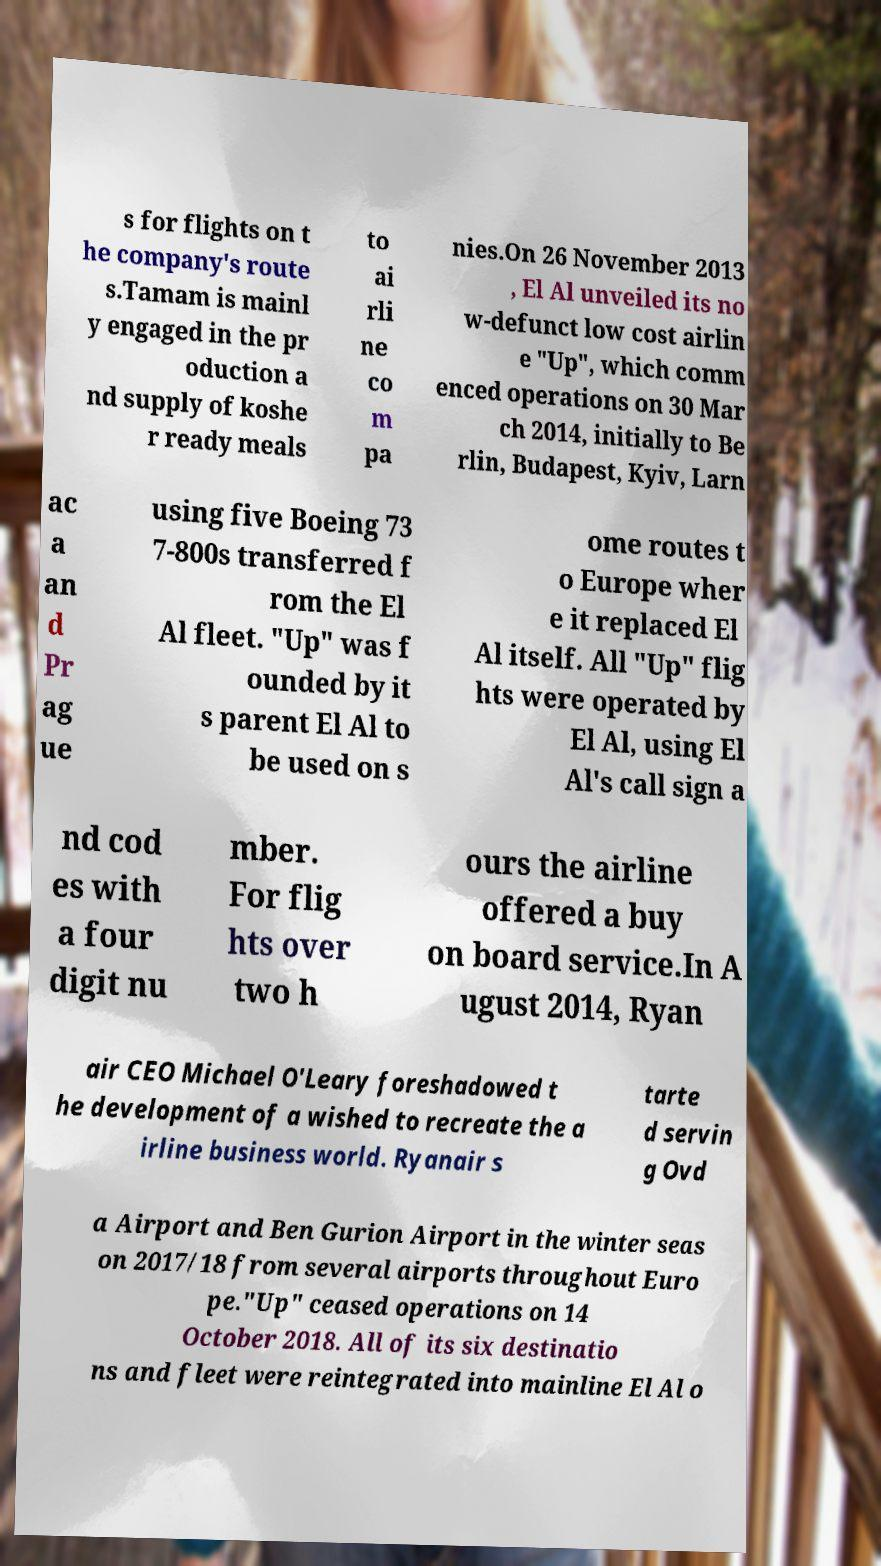Please read and relay the text visible in this image. What does it say? s for flights on t he company's route s.Tamam is mainl y engaged in the pr oduction a nd supply of koshe r ready meals to ai rli ne co m pa nies.On 26 November 2013 , El Al unveiled its no w-defunct low cost airlin e "Up", which comm enced operations on 30 Mar ch 2014, initially to Be rlin, Budapest, Kyiv, Larn ac a an d Pr ag ue using five Boeing 73 7-800s transferred f rom the El Al fleet. "Up" was f ounded by it s parent El Al to be used on s ome routes t o Europe wher e it replaced El Al itself. All "Up" flig hts were operated by El Al, using El Al's call sign a nd cod es with a four digit nu mber. For flig hts over two h ours the airline offered a buy on board service.In A ugust 2014, Ryan air CEO Michael O'Leary foreshadowed t he development of a wished to recreate the a irline business world. Ryanair s tarte d servin g Ovd a Airport and Ben Gurion Airport in the winter seas on 2017/18 from several airports throughout Euro pe."Up" ceased operations on 14 October 2018. All of its six destinatio ns and fleet were reintegrated into mainline El Al o 